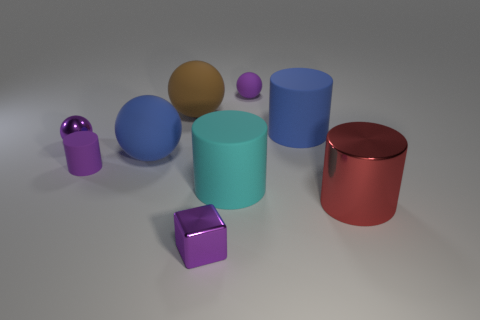What shape is the blue matte object that is on the left side of the large rubber cylinder on the left side of the small sphere behind the large blue matte cylinder?
Ensure brevity in your answer.  Sphere. How many other things are the same shape as the red shiny thing?
Your response must be concise. 3. How many metallic things are either large cyan cylinders or big things?
Your response must be concise. 1. What is the large ball that is behind the large matte cylinder that is to the right of the purple matte sphere made of?
Your response must be concise. Rubber. Is the number of purple cubes that are to the right of the purple rubber sphere greater than the number of tiny rubber cylinders?
Ensure brevity in your answer.  No. Are there any brown spheres that have the same material as the big cyan object?
Your answer should be very brief. Yes. Is the shape of the tiny purple shiny thing in front of the cyan cylinder the same as  the big cyan rubber thing?
Offer a terse response. No. What number of brown rubber things are to the right of the tiny sphere that is in front of the small object that is to the right of the purple block?
Provide a succinct answer. 1. Are there fewer purple balls that are to the left of the brown ball than small purple rubber cylinders that are right of the tiny purple cube?
Ensure brevity in your answer.  No. There is a small object that is the same shape as the big red object; what color is it?
Provide a short and direct response. Purple. 